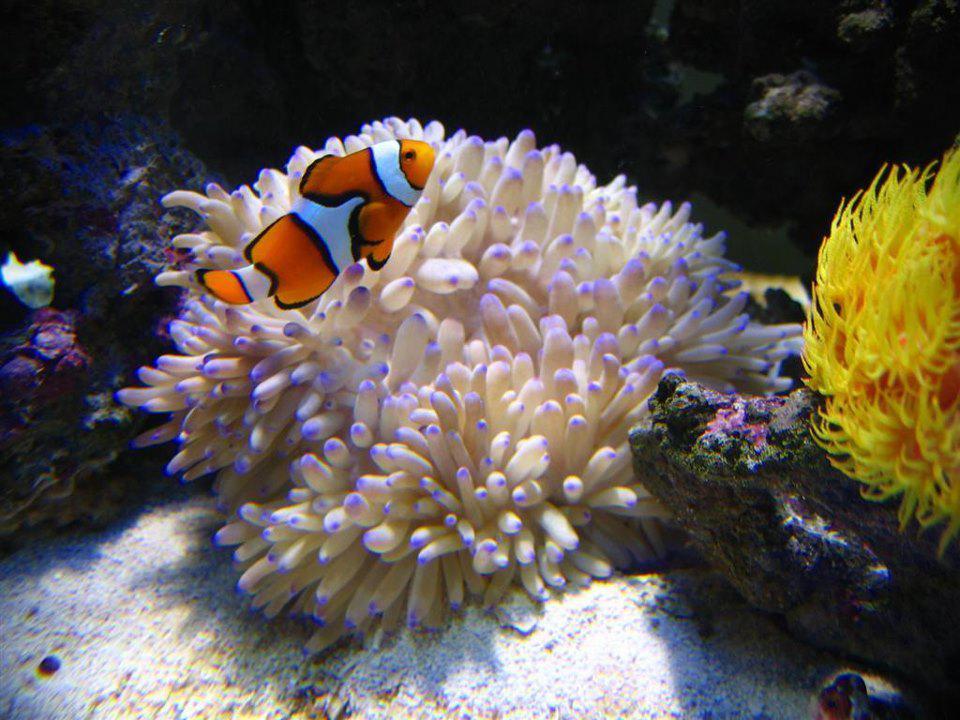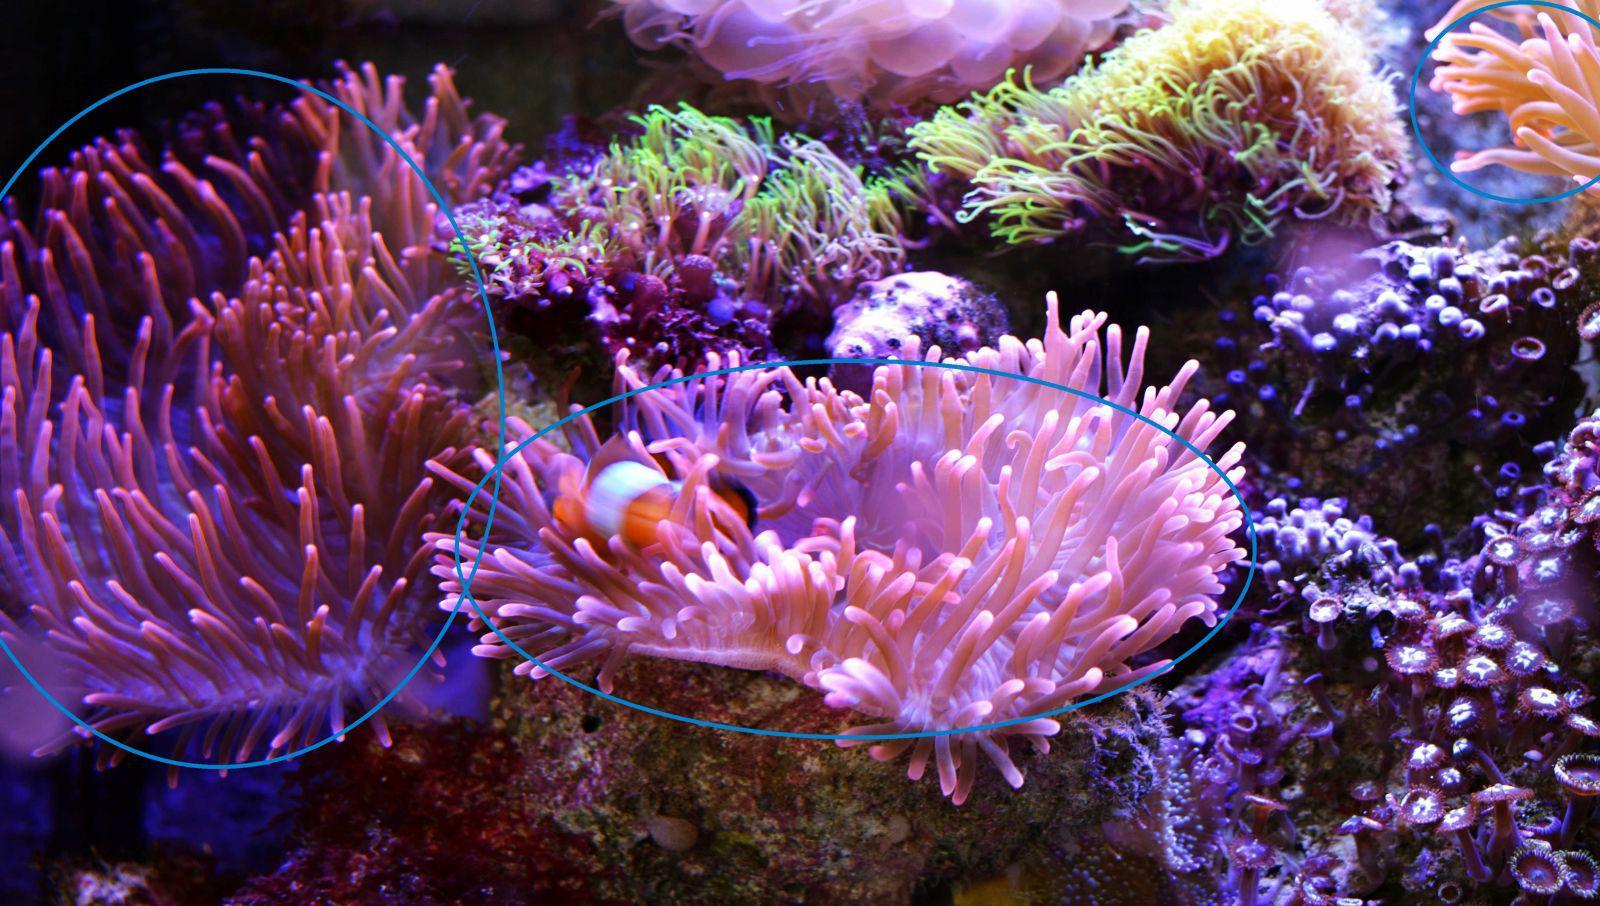The first image is the image on the left, the second image is the image on the right. Examine the images to the left and right. Is the description "At least one fish is orange." accurate? Answer yes or no. Yes. The first image is the image on the left, the second image is the image on the right. Evaluate the accuracy of this statement regarding the images: "The left and right image contains the same number of fish.". Is it true? Answer yes or no. Yes. 